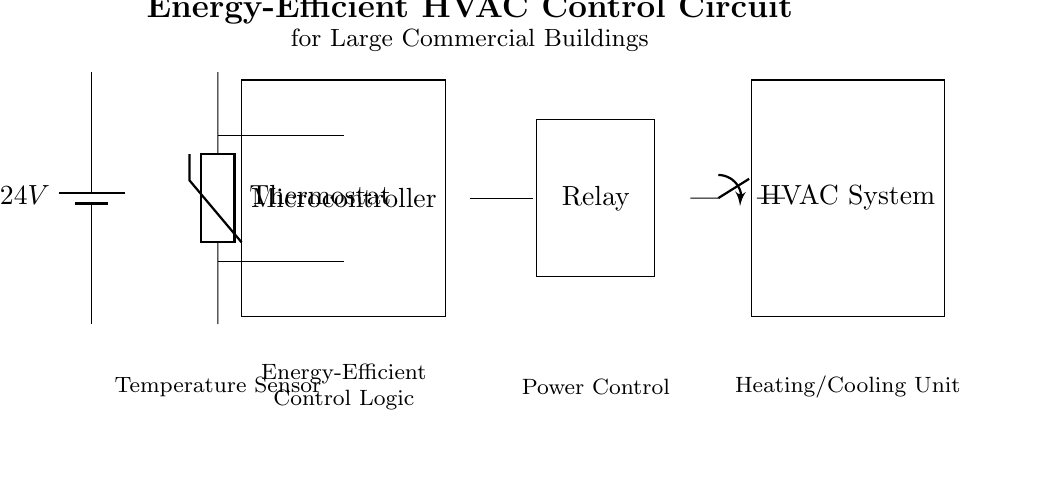What is the voltage of the battery? The voltage of the battery is indicated as 24V in the circuit diagram. It is the potential difference provided by the battery for the circuit.
Answer: 24V What component is used to sense temperature? The component that senses temperature is labeled as a thermostat in the circuit diagram, which is a type of thermistor.
Answer: Thermostat What is the role of the microcontroller in this circuit? The microcontroller in this circuit is responsible for energy-efficient control logic, processing signals from the thermostat, and controlling the relay.
Answer: Energy-Efficient Control Logic How does the microcontroller connect to the thermostat? The microcontroller connects to the thermostat via two lines: one line for the temperature signal and another for control feedback, both coming from the thermostat.
Answer: Two lines What happens when the relay is activated? When the relay is activated by the microcontroller, it controls the switch that connects or disconnects power to the HVAC system, effectively turning it on or off.
Answer: Controls HVAC Which component receives power control? The relay receives power control from the microcontroller, which is indicated by the connection shown between them in the circuit.
Answer: Relay What type of system is indicated at the end of the circuit? The system indicated at the end of the circuit is an HVAC system, which stands for Heating, Ventilation, and Air Conditioning.
Answer: HVAC System 